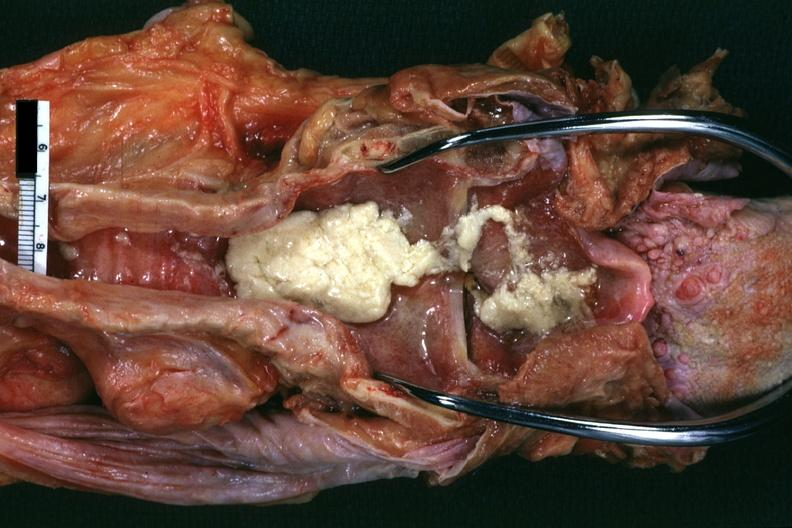s aspiration present?
Answer the question using a single word or phrase. Yes 